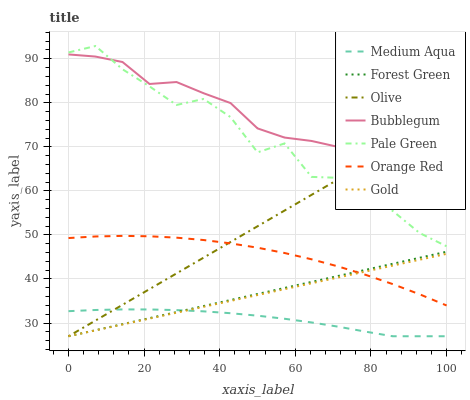Does Medium Aqua have the minimum area under the curve?
Answer yes or no. Yes. Does Bubblegum have the maximum area under the curve?
Answer yes or no. Yes. Does Forest Green have the minimum area under the curve?
Answer yes or no. No. Does Forest Green have the maximum area under the curve?
Answer yes or no. No. Is Gold the smoothest?
Answer yes or no. Yes. Is Pale Green the roughest?
Answer yes or no. Yes. Is Bubblegum the smoothest?
Answer yes or no. No. Is Bubblegum the roughest?
Answer yes or no. No. Does Gold have the lowest value?
Answer yes or no. Yes. Does Bubblegum have the lowest value?
Answer yes or no. No. Does Pale Green have the highest value?
Answer yes or no. Yes. Does Bubblegum have the highest value?
Answer yes or no. No. Is Gold less than Bubblegum?
Answer yes or no. Yes. Is Pale Green greater than Forest Green?
Answer yes or no. Yes. Does Orange Red intersect Gold?
Answer yes or no. Yes. Is Orange Red less than Gold?
Answer yes or no. No. Is Orange Red greater than Gold?
Answer yes or no. No. Does Gold intersect Bubblegum?
Answer yes or no. No. 